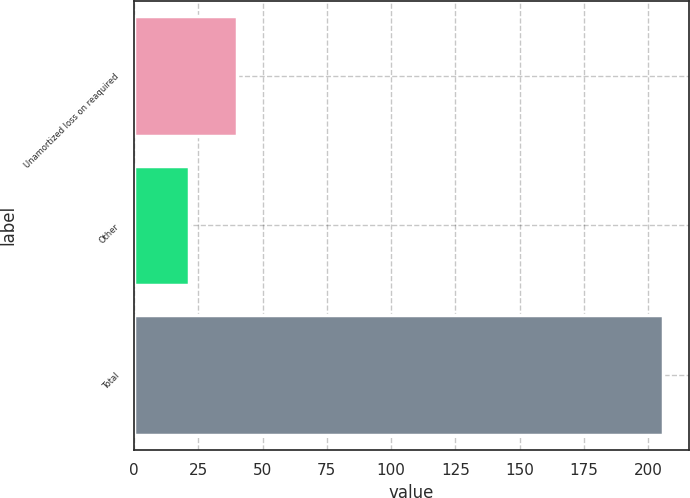<chart> <loc_0><loc_0><loc_500><loc_500><bar_chart><fcel>Unamortized loss on reaquired<fcel>Other<fcel>Total<nl><fcel>39.92<fcel>21.5<fcel>205.7<nl></chart> 